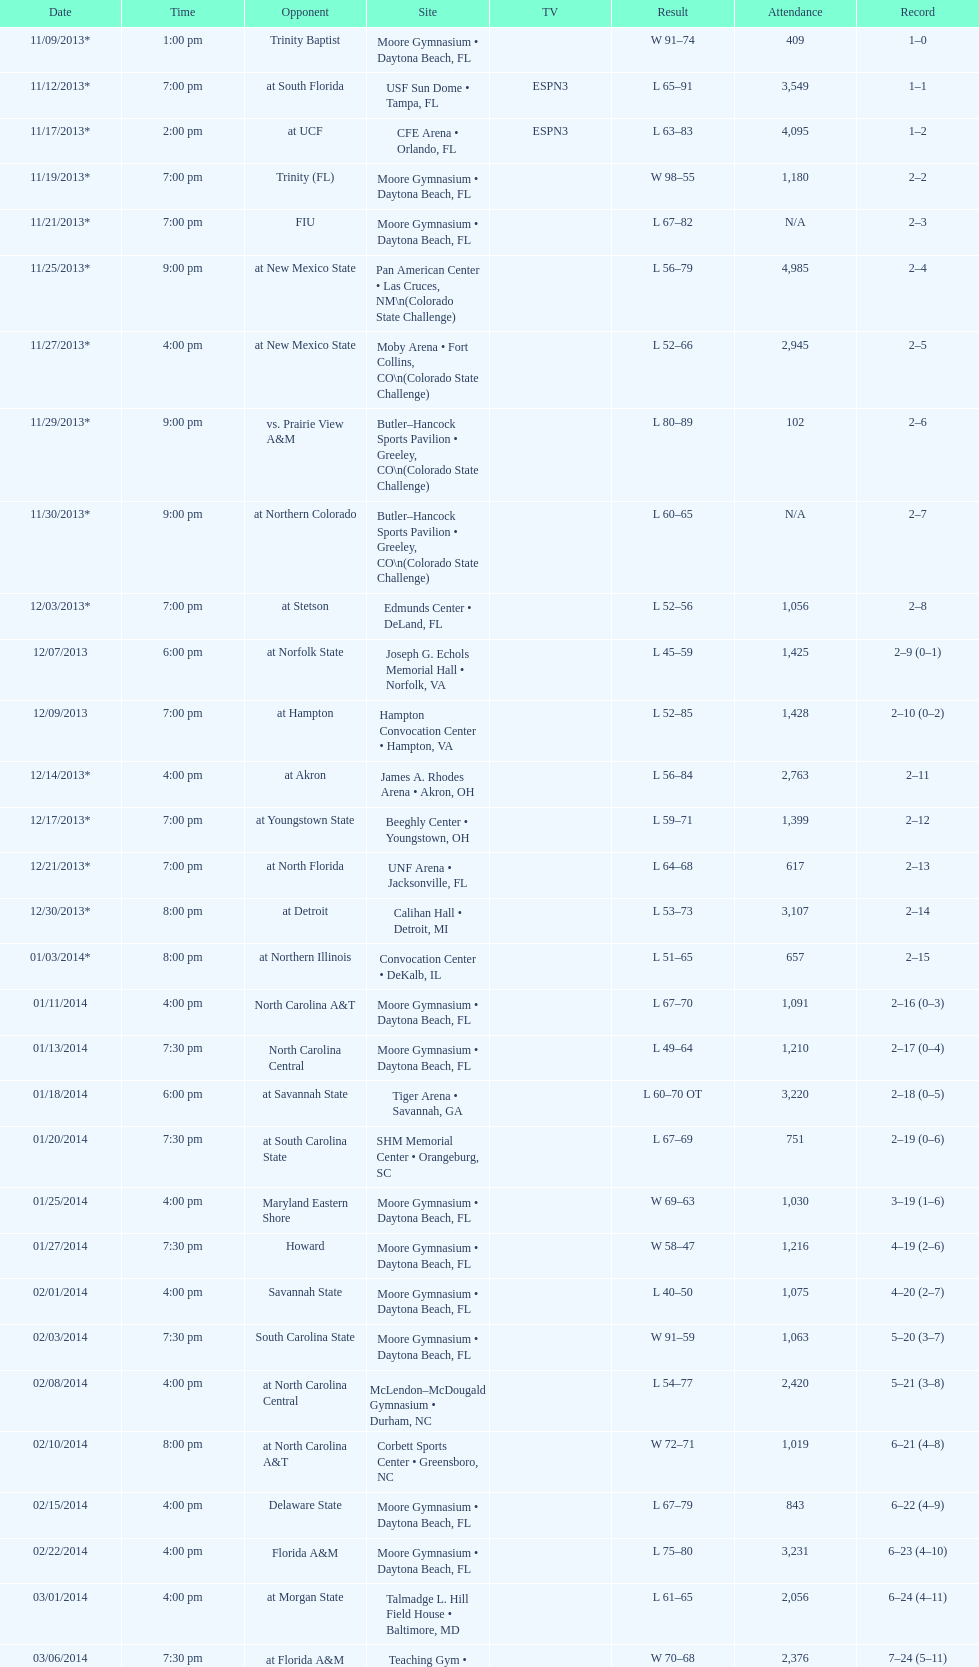By how many people was the attendance on 11/25/2013 greater than on 12/21/2013? 4368. 